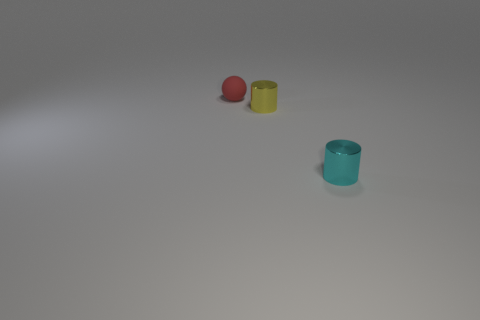There is a thing behind the yellow metal cylinder; what is its shape?
Make the answer very short. Sphere. How many other things are the same size as the cyan metallic object?
Provide a short and direct response. 2. Does the thing right of the yellow metal cylinder have the same shape as the tiny shiny object that is to the left of the tiny cyan shiny cylinder?
Provide a short and direct response. Yes. What number of small cyan objects are left of the small cyan cylinder?
Ensure brevity in your answer.  0. What color is the tiny metallic cylinder that is left of the tiny cyan cylinder?
Provide a short and direct response. Yellow. What is the color of the other object that is the same shape as the yellow object?
Your response must be concise. Cyan. Is there any other thing that is the same color as the small sphere?
Your answer should be very brief. No. Is the number of small gray rubber cylinders greater than the number of red matte spheres?
Give a very brief answer. No. Does the small cyan object have the same material as the tiny ball?
Offer a very short reply. No. How many tiny yellow cylinders are made of the same material as the sphere?
Provide a short and direct response. 0. 